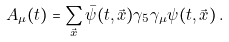Convert formula to latex. <formula><loc_0><loc_0><loc_500><loc_500>A _ { \mu } ( t ) = \sum _ { \vec { x } } \bar { \psi } ( t , \vec { x } ) \gamma _ { 5 } \gamma _ { \mu } \psi ( t , \vec { x } ) \, .</formula> 